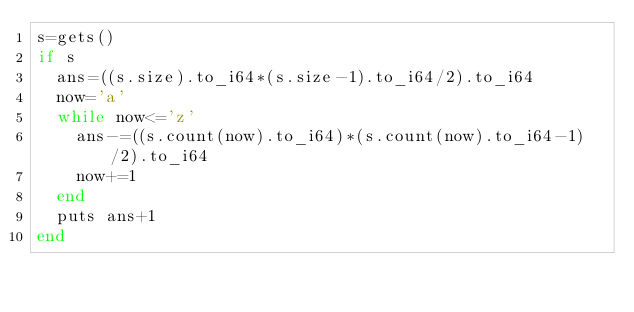<code> <loc_0><loc_0><loc_500><loc_500><_Crystal_>s=gets()
if s
	ans=((s.size).to_i64*(s.size-1).to_i64/2).to_i64
	now='a'
	while now<='z'
		ans-=((s.count(now).to_i64)*(s.count(now).to_i64-1)/2).to_i64
		now+=1
	end
	puts ans+1
end</code> 